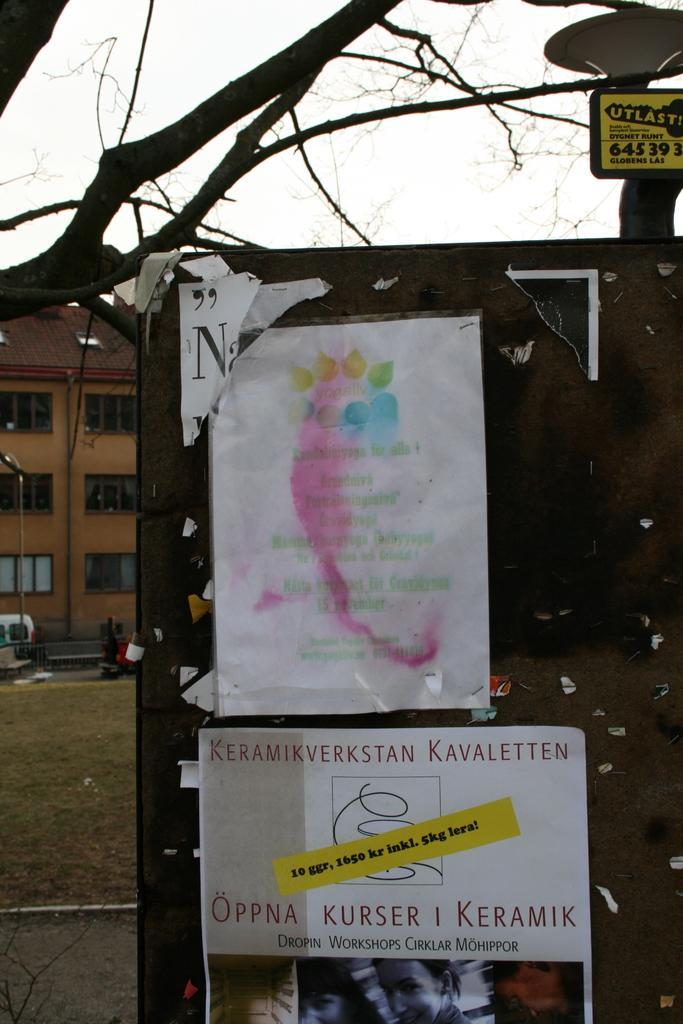Can you describe this image briefly? In this image, we can see posts placed on the board and in the background, there are trees, buildings, poles and we can see a vehicle. 